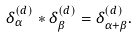Convert formula to latex. <formula><loc_0><loc_0><loc_500><loc_500>\delta _ { \alpha } ^ { ( d ) } \ast \delta _ { \beta } ^ { ( d ) } = \delta _ { \alpha + \beta } ^ { ( d ) } .</formula> 